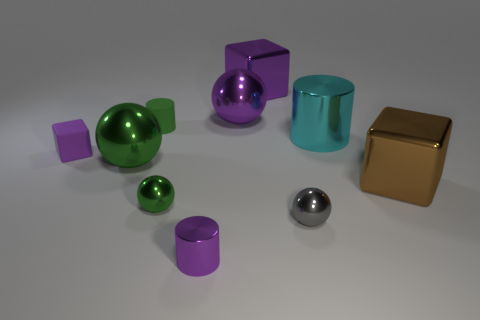Subtract all gray metallic balls. How many balls are left? 3 Subtract all red blocks. How many green balls are left? 2 Subtract 1 cylinders. How many cylinders are left? 2 Subtract all gray spheres. How many spheres are left? 3 Subtract all red cylinders. Subtract all blue balls. How many cylinders are left? 3 Subtract all blocks. How many objects are left? 7 Subtract 0 blue cylinders. How many objects are left? 10 Subtract all small rubber cylinders. Subtract all tiny rubber cylinders. How many objects are left? 8 Add 9 big green spheres. How many big green spheres are left? 10 Add 1 blue metal spheres. How many blue metal spheres exist? 1 